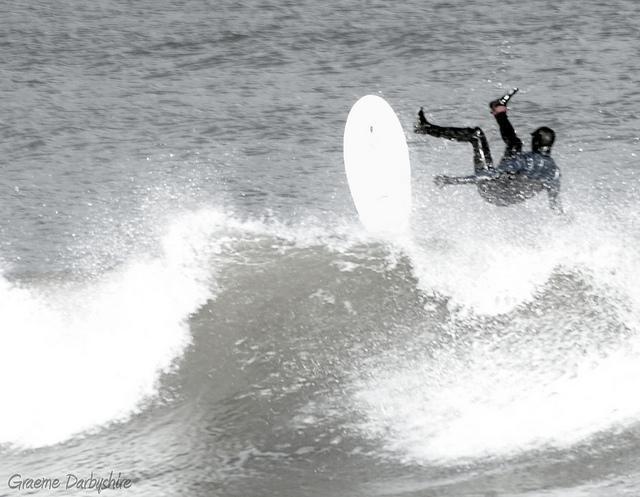How many surfboards are in the picture?
Give a very brief answer. 1. 